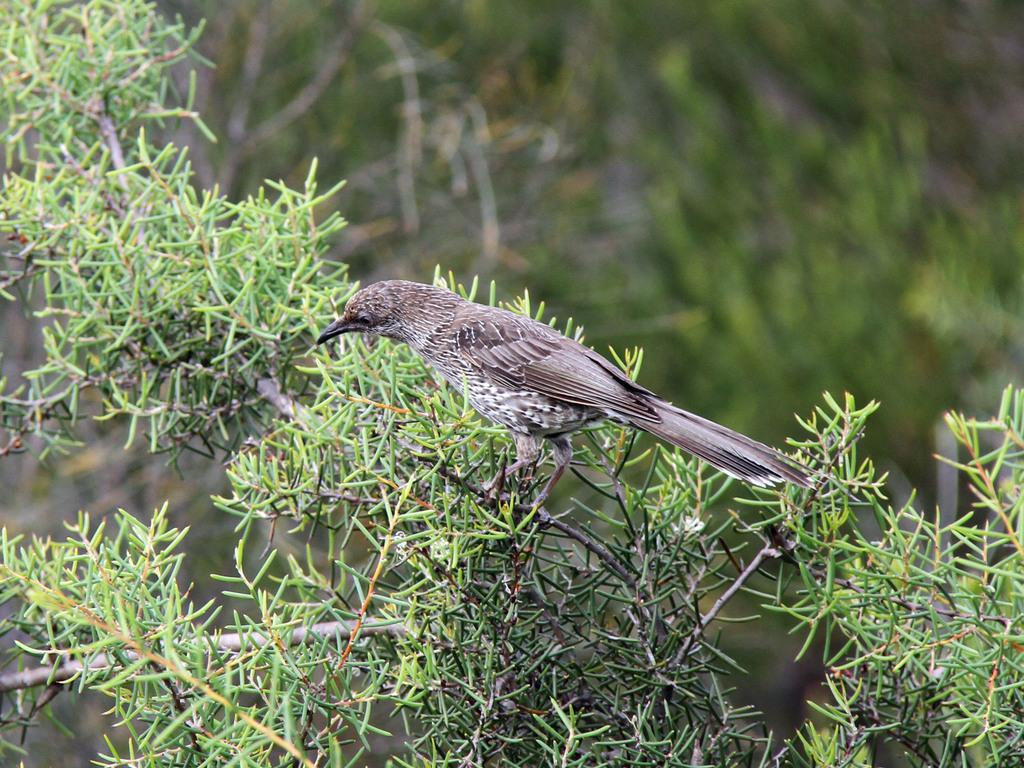What type of animal is in the image? There is a bird in the image. Where is the bird located? The bird is on a tree. What can be seen in the background of the image? There are plants in the background of the image. How would you describe the background of the image? The background of the image is blurred. Reasoning: Let' Let's think step by step in order to produce the conversation. We start by identifying the main subject in the image, which is the bird. Then, we describe the bird's location, which is on a tree. Next, we mention the background elements, which are plants. Finally, we describe the background's appearance, which is blurred. Each question is designed to elicit a specific detail about the image that is known from the provided facts. Absurd Question/Answer: How many oranges are hanging from the tree in the image? There are no oranges present in the image; it features a bird on a tree. What type of army is visible in the image? There is no army present in the image; it features a bird on a tree and plants in the background. How many dimes are scattered around the tree in the image? There are no dimes present in the image; it features a bird on a tree and plants in the background. 